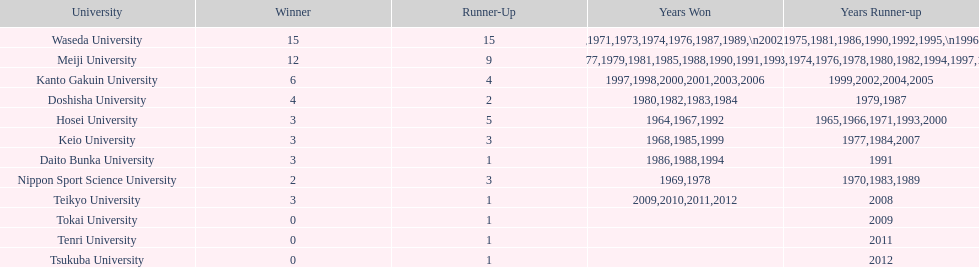Hosei was victorious in 196 Waseda University. 